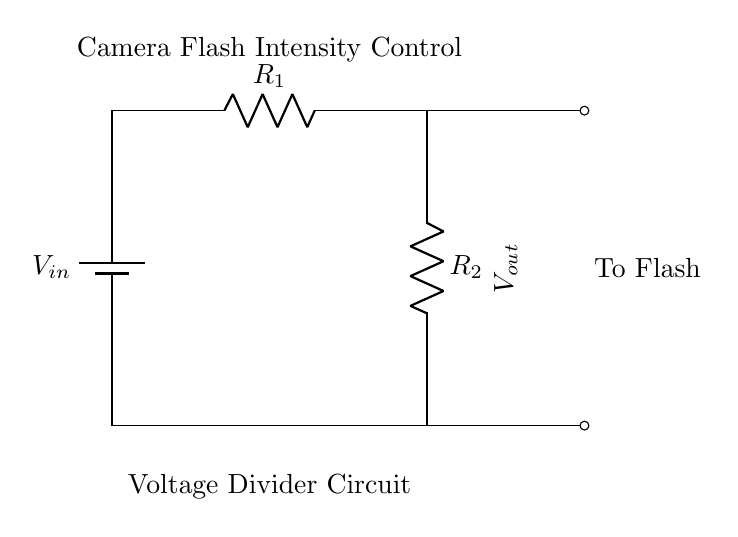What is the input voltage in the circuit? The input voltage is labeled as V_in and is positioned at the top left side of the circuit.
Answer: V_in What components are used in the circuit diagram? The circuit includes a battery as the voltage source (V_in) and two resistors labeled R_1 and R_2, along with output connections for controlling the camera flash intensity.
Answer: Battery, R_1, R_2 What is the purpose of the voltage divider in this circuit? The voltage divider adjusts the voltage output (V_out) which regulates the intensity of the camera flash by proportioning the input voltage across the two resistors.
Answer: Adjust flash intensity How is the output voltage related to R_1 and R_2? The output voltage (V_out) is determined by the formula V_out = V_in * (R_2 / (R_1 + R_2)), showing how the two resistors divide the input voltage.
Answer: V_out = V_in * (R_2 / (R_1 + R_2)) What would happen if R_1 is much larger than R_2? If R_1 is much larger than R_2, most of the input voltage (V_in) will drop across R_1, resulting in a lower output voltage (V_out) which reduces the flash intensity.
Answer: Lower output voltage What is V_out in this specific application? V_out is the voltage that goes to the flash, which is the reduced voltage obtained from the voltage divider setup that regulates the intensity of the flash light.
Answer: Voltage to flash What does the label "Camera Flash Intensity Control" indicate in the diagram? The label highlights the intended application of the circuit, emphasizing that it is used to control and adjust the intensity of the flash based on the output voltage.
Answer: Flash intensity control 